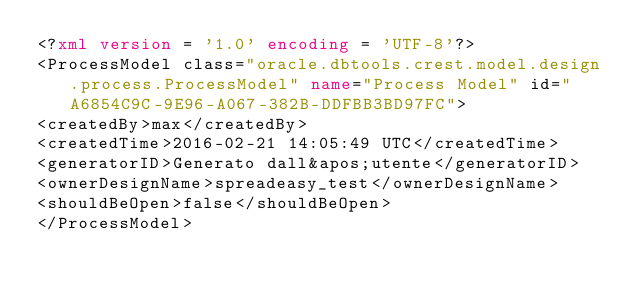Convert code to text. <code><loc_0><loc_0><loc_500><loc_500><_XML_><?xml version = '1.0' encoding = 'UTF-8'?>
<ProcessModel class="oracle.dbtools.crest.model.design.process.ProcessModel" name="Process Model" id="A6854C9C-9E96-A067-382B-DDFBB3BD97FC">
<createdBy>max</createdBy>
<createdTime>2016-02-21 14:05:49 UTC</createdTime>
<generatorID>Generato dall&apos;utente</generatorID>
<ownerDesignName>spreadeasy_test</ownerDesignName>
<shouldBeOpen>false</shouldBeOpen>
</ProcessModel></code> 